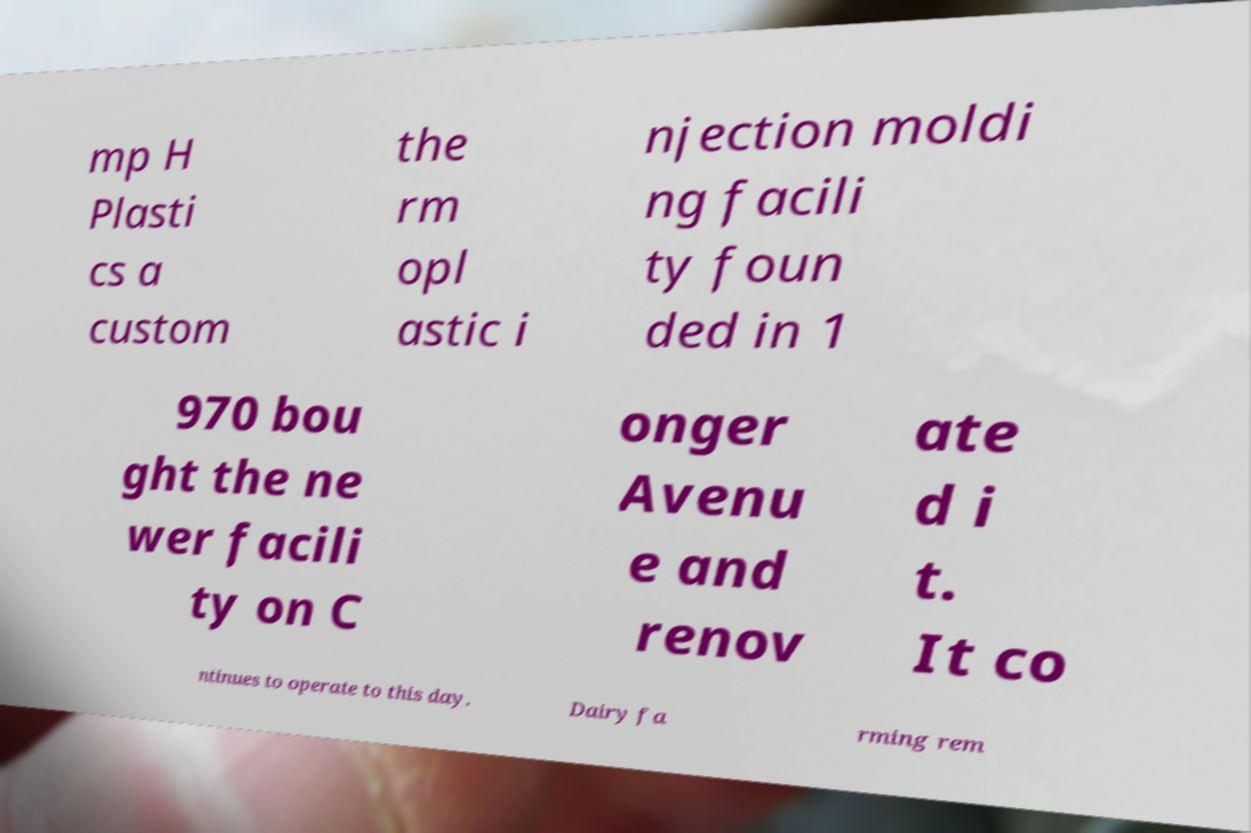Can you accurately transcribe the text from the provided image for me? mp H Plasti cs a custom the rm opl astic i njection moldi ng facili ty foun ded in 1 970 bou ght the ne wer facili ty on C onger Avenu e and renov ate d i t. It co ntinues to operate to this day. Dairy fa rming rem 